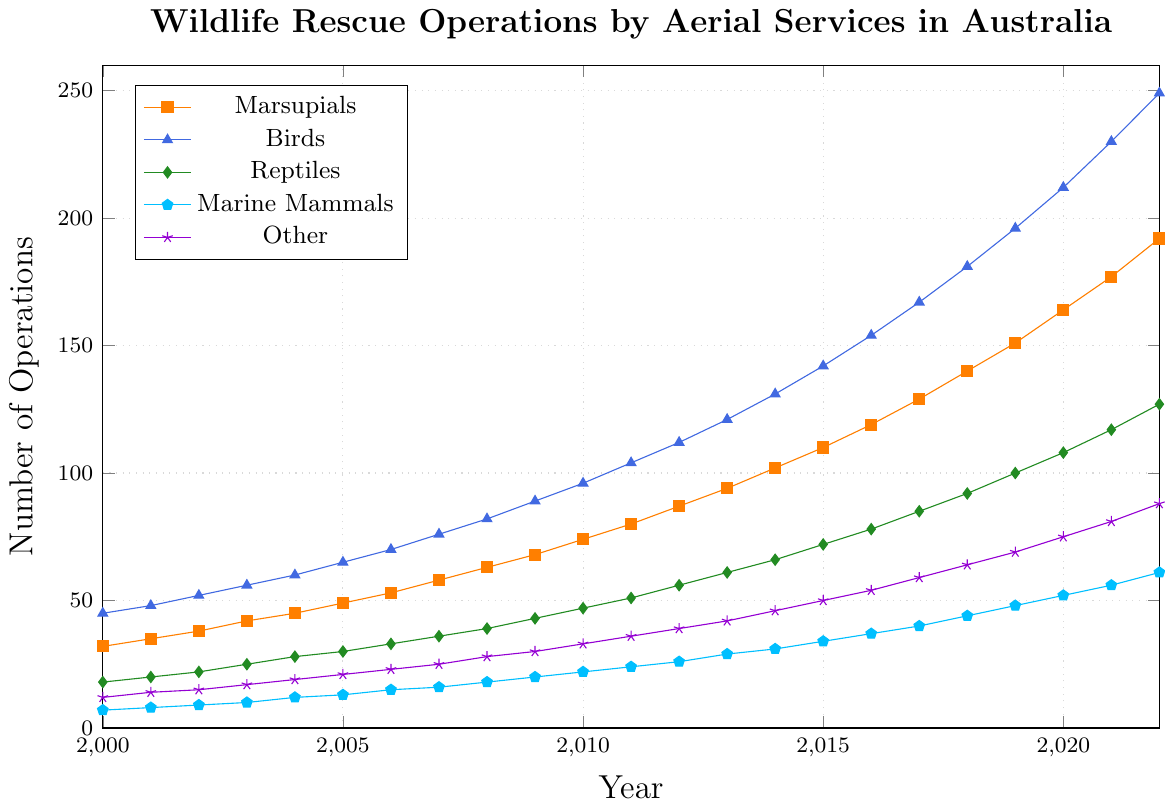What is the general trend for the number of wildlife rescue operations for marine mammals from 2000 to 2022? To observe the general trend, trace the line representing marine mammals from left to right. The line consistently increases over the years, showing a rising trend in the number of wildlife rescue operations for marine mammals.
Answer: Rising Which animal type had the highest number of rescue operations in 2022? Look at the end of the lines in the plot for the year 2022. The line for birds is the highest among all animal types.
Answer: Birds Compare the number of rescue operations conducted for marsupials and reptiles in 2015. Which was higher and by how much? From the plot, find the points in 2015 for both marsupials and reptiles. Marsupials had 110 operations, and reptiles had 72 operations. The difference is 110 - 72 = 38.
Answer: Marsupials by 38 In which year did the number of rescue operations for birds first exceed 100? Follow the line for birds and find the year where the y-value first exceeds 100. This occurs in 2011.
Answer: 2011 How many more rescue operations were conducted for reptiles compared to marine mammals in 2020? Locate the 2020 data points for both reptiles and marine mammals. Reptiles had 108 operations, and marine mammals had 52 operations. The difference is 108 - 52 = 56.
Answer: 56 What is the overall increase in the number of rescue operations for birds from 2000 to 2022? Look at the points for birds in 2000 and 2022. Birds had 45 operations in 2000 and 249 in 2022. The increase is 249 - 45 = 204.
Answer: 204 Which animal type saw the least increase in rescue operations from 2000 to 2022? Compare the overall increases for all animal types from 2000 to 2022 by subtracting the 2000 value from the 2022 value for each type. Marine mammals increased from 7 to 61, which is the smallest increase (61 - 7 = 54).
Answer: Marine mammals Based on the visual attributes, which animal type has the line colored in green? By identifying the color-coded lines, the green line represents reptiles.
Answer: Reptiles What is the rate of increase per year for marsupial rescue operations from 2000 to 2010? Calculate the rate by finding the total increase from 2000 to 2010 and dividing by the number of years. Marsupials increased from 32 to 74 over 10 years (74 - 32 = 42), so the rate is 42/10 = 4.2 operations per year.
Answer: 4.2 operations per year 